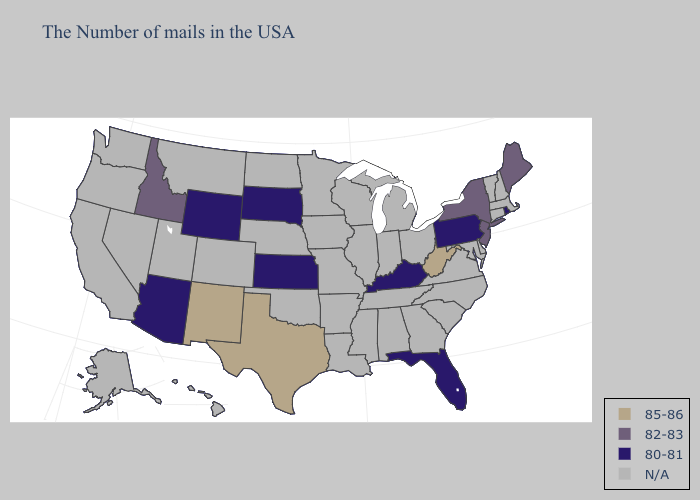What is the highest value in the West ?
Be succinct. 85-86. Does the map have missing data?
Answer briefly. Yes. Does Rhode Island have the highest value in the Northeast?
Answer briefly. No. What is the highest value in the South ?
Write a very short answer. 85-86. Does Wyoming have the lowest value in the USA?
Concise answer only. Yes. Which states have the lowest value in the MidWest?
Short answer required. Kansas, South Dakota. Name the states that have a value in the range 80-81?
Concise answer only. Rhode Island, Pennsylvania, Florida, Kentucky, Kansas, South Dakota, Wyoming, Arizona. Does New Mexico have the highest value in the USA?
Short answer required. Yes. Among the states that border Oklahoma , which have the lowest value?
Write a very short answer. Kansas. Does Kentucky have the highest value in the South?
Answer briefly. No. Name the states that have a value in the range 85-86?
Be succinct. West Virginia, Texas, New Mexico. Name the states that have a value in the range 85-86?
Concise answer only. West Virginia, Texas, New Mexico. What is the lowest value in the USA?
Give a very brief answer. 80-81. What is the value of New Jersey?
Short answer required. 82-83. Does the map have missing data?
Concise answer only. Yes. 